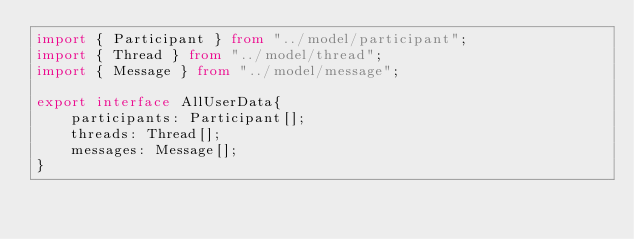<code> <loc_0><loc_0><loc_500><loc_500><_TypeScript_>import { Participant } from "../model/participant";
import { Thread } from "../model/thread";
import { Message } from "../model/message";

export interface AllUserData{
    participants: Participant[];
    threads: Thread[];
    messages: Message[];
}</code> 